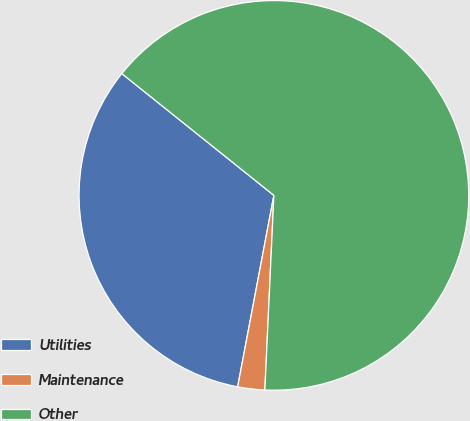Convert chart. <chart><loc_0><loc_0><loc_500><loc_500><pie_chart><fcel>Utilities<fcel>Maintenance<fcel>Other<nl><fcel>32.77%<fcel>2.24%<fcel>64.99%<nl></chart> 